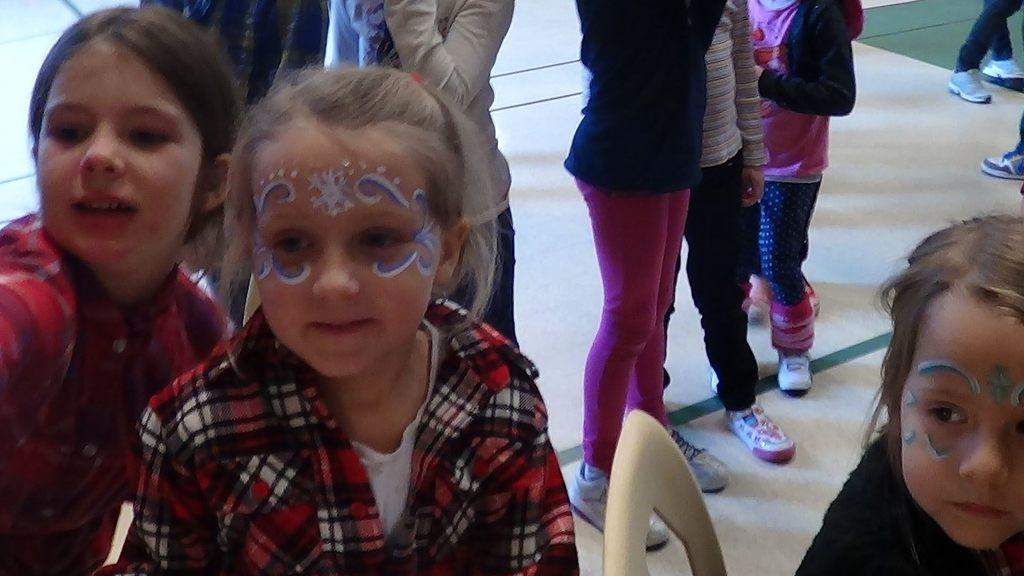What can be seen in the image? There are children in the image. What are some of the children wearing? Some of the children are wearing costumes. Where are the costumes located on the children? The costumes are on the children's faces. What else can be observed about the children in the background? There are other children standing on the floor in the background. What type of polish is being applied to the children's faces in the image? There is no indication in the image that any polish is being applied to the children's faces. 